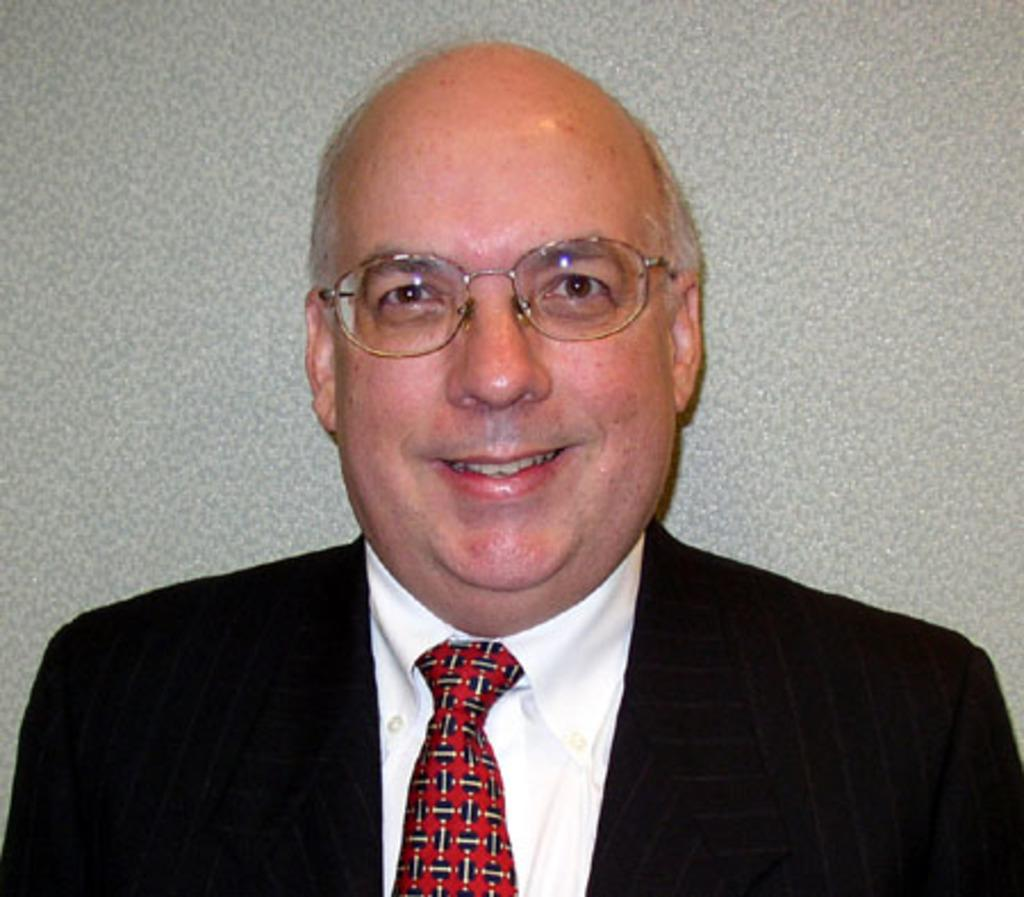What is the main subject of the image? There is a person in the image. What is the person wearing on their upper body? The person is wearing a white shirt, a red tie, and a black blazer. How is the person's facial expression in the image? The person is smiling in the image. What color is the background of the image? The background of the image is ash colored. How many pets are visible in the image? There are no pets present in the image. What type of cent is being used by the person in the image? There is no cent visible in the image, and the person is not using any cent. 